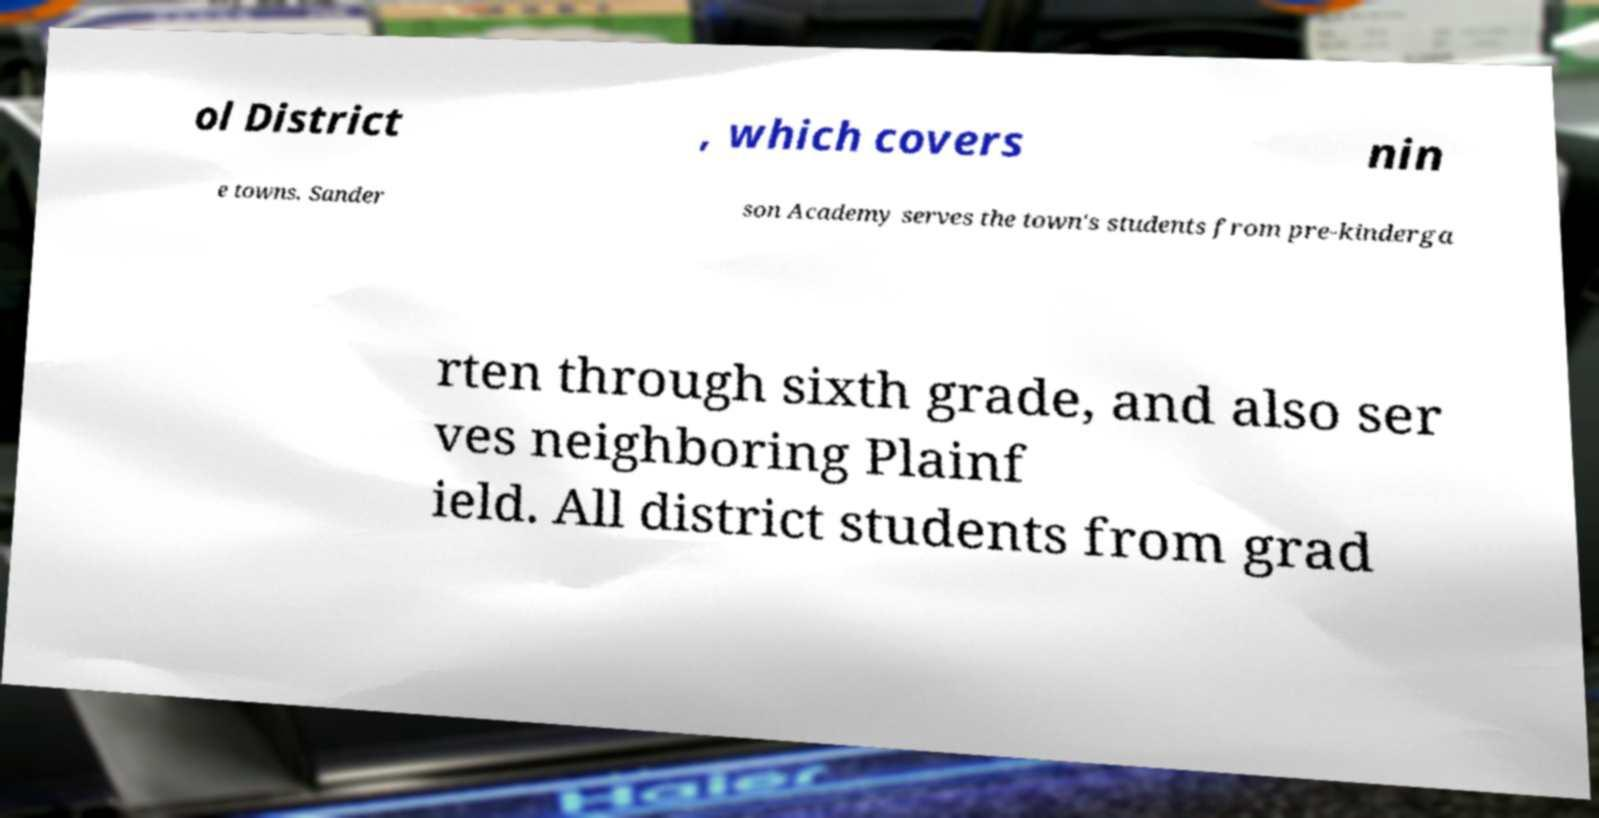For documentation purposes, I need the text within this image transcribed. Could you provide that? ol District , which covers nin e towns. Sander son Academy serves the town's students from pre-kinderga rten through sixth grade, and also ser ves neighboring Plainf ield. All district students from grad 